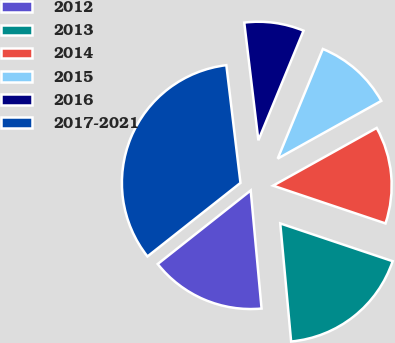Convert chart. <chart><loc_0><loc_0><loc_500><loc_500><pie_chart><fcel>2012<fcel>2013<fcel>2014<fcel>2015<fcel>2016<fcel>2017-2021<nl><fcel>15.81%<fcel>18.38%<fcel>13.25%<fcel>10.69%<fcel>8.12%<fcel>33.75%<nl></chart> 